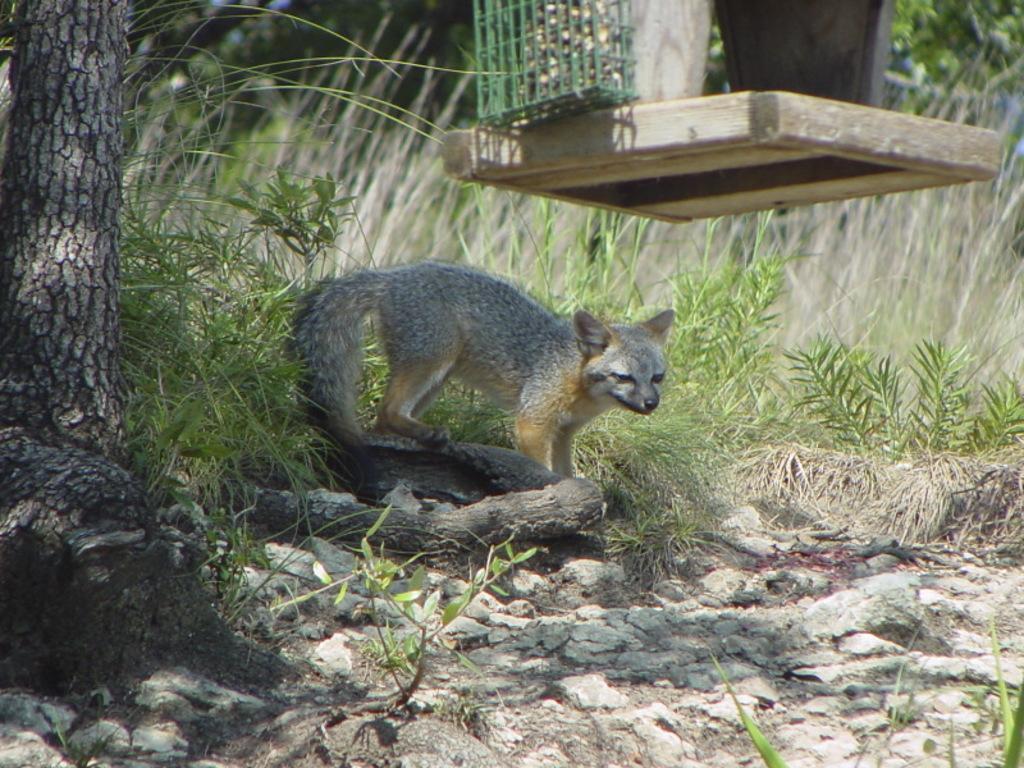Can you describe this image briefly? In this image we can see animal, plants, tree and rocks. Above this animal there is a platform. Above that platform there is a mesh and things. Background it is blur. 